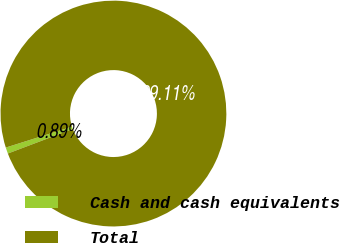<chart> <loc_0><loc_0><loc_500><loc_500><pie_chart><fcel>Cash and cash equivalents<fcel>Total<nl><fcel>0.89%<fcel>99.11%<nl></chart> 